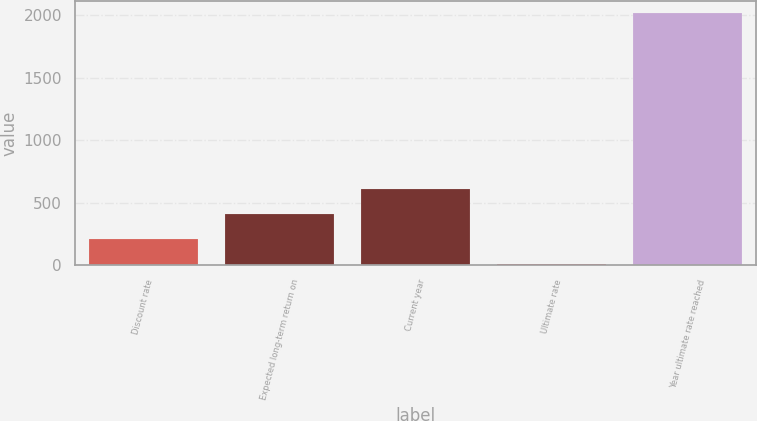Convert chart. <chart><loc_0><loc_0><loc_500><loc_500><bar_chart><fcel>Discount rate<fcel>Expected long-term return on<fcel>Current year<fcel>Ultimate rate<fcel>Year ultimate rate reached<nl><fcel>206<fcel>407<fcel>608<fcel>5<fcel>2015<nl></chart> 